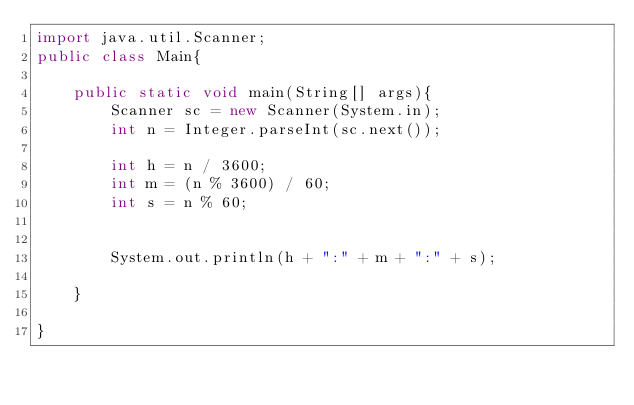<code> <loc_0><loc_0><loc_500><loc_500><_Java_>import java.util.Scanner;
public class Main{

    public static void main(String[] args){
        Scanner sc = new Scanner(System.in);
        int n = Integer.parseInt(sc.next());
        
        int h = n / 3600;
        int m = (n % 3600) / 60;
        int s = n % 60;


        System.out.println(h + ":" + m + ":" + s);

    }

}

</code> 